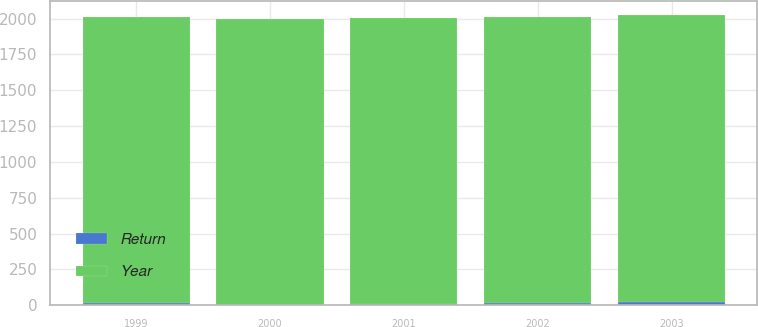Convert chart. <chart><loc_0><loc_0><loc_500><loc_500><stacked_bar_chart><ecel><fcel>2003<fcel>2002<fcel>2001<fcel>2000<fcel>1999<nl><fcel>Return<fcel>25<fcel>13.4<fcel>6.1<fcel>3.5<fcel>18.2<nl><fcel>Year<fcel>1998<fcel>1997<fcel>1996<fcel>1995<fcel>1994<nl></chart> 